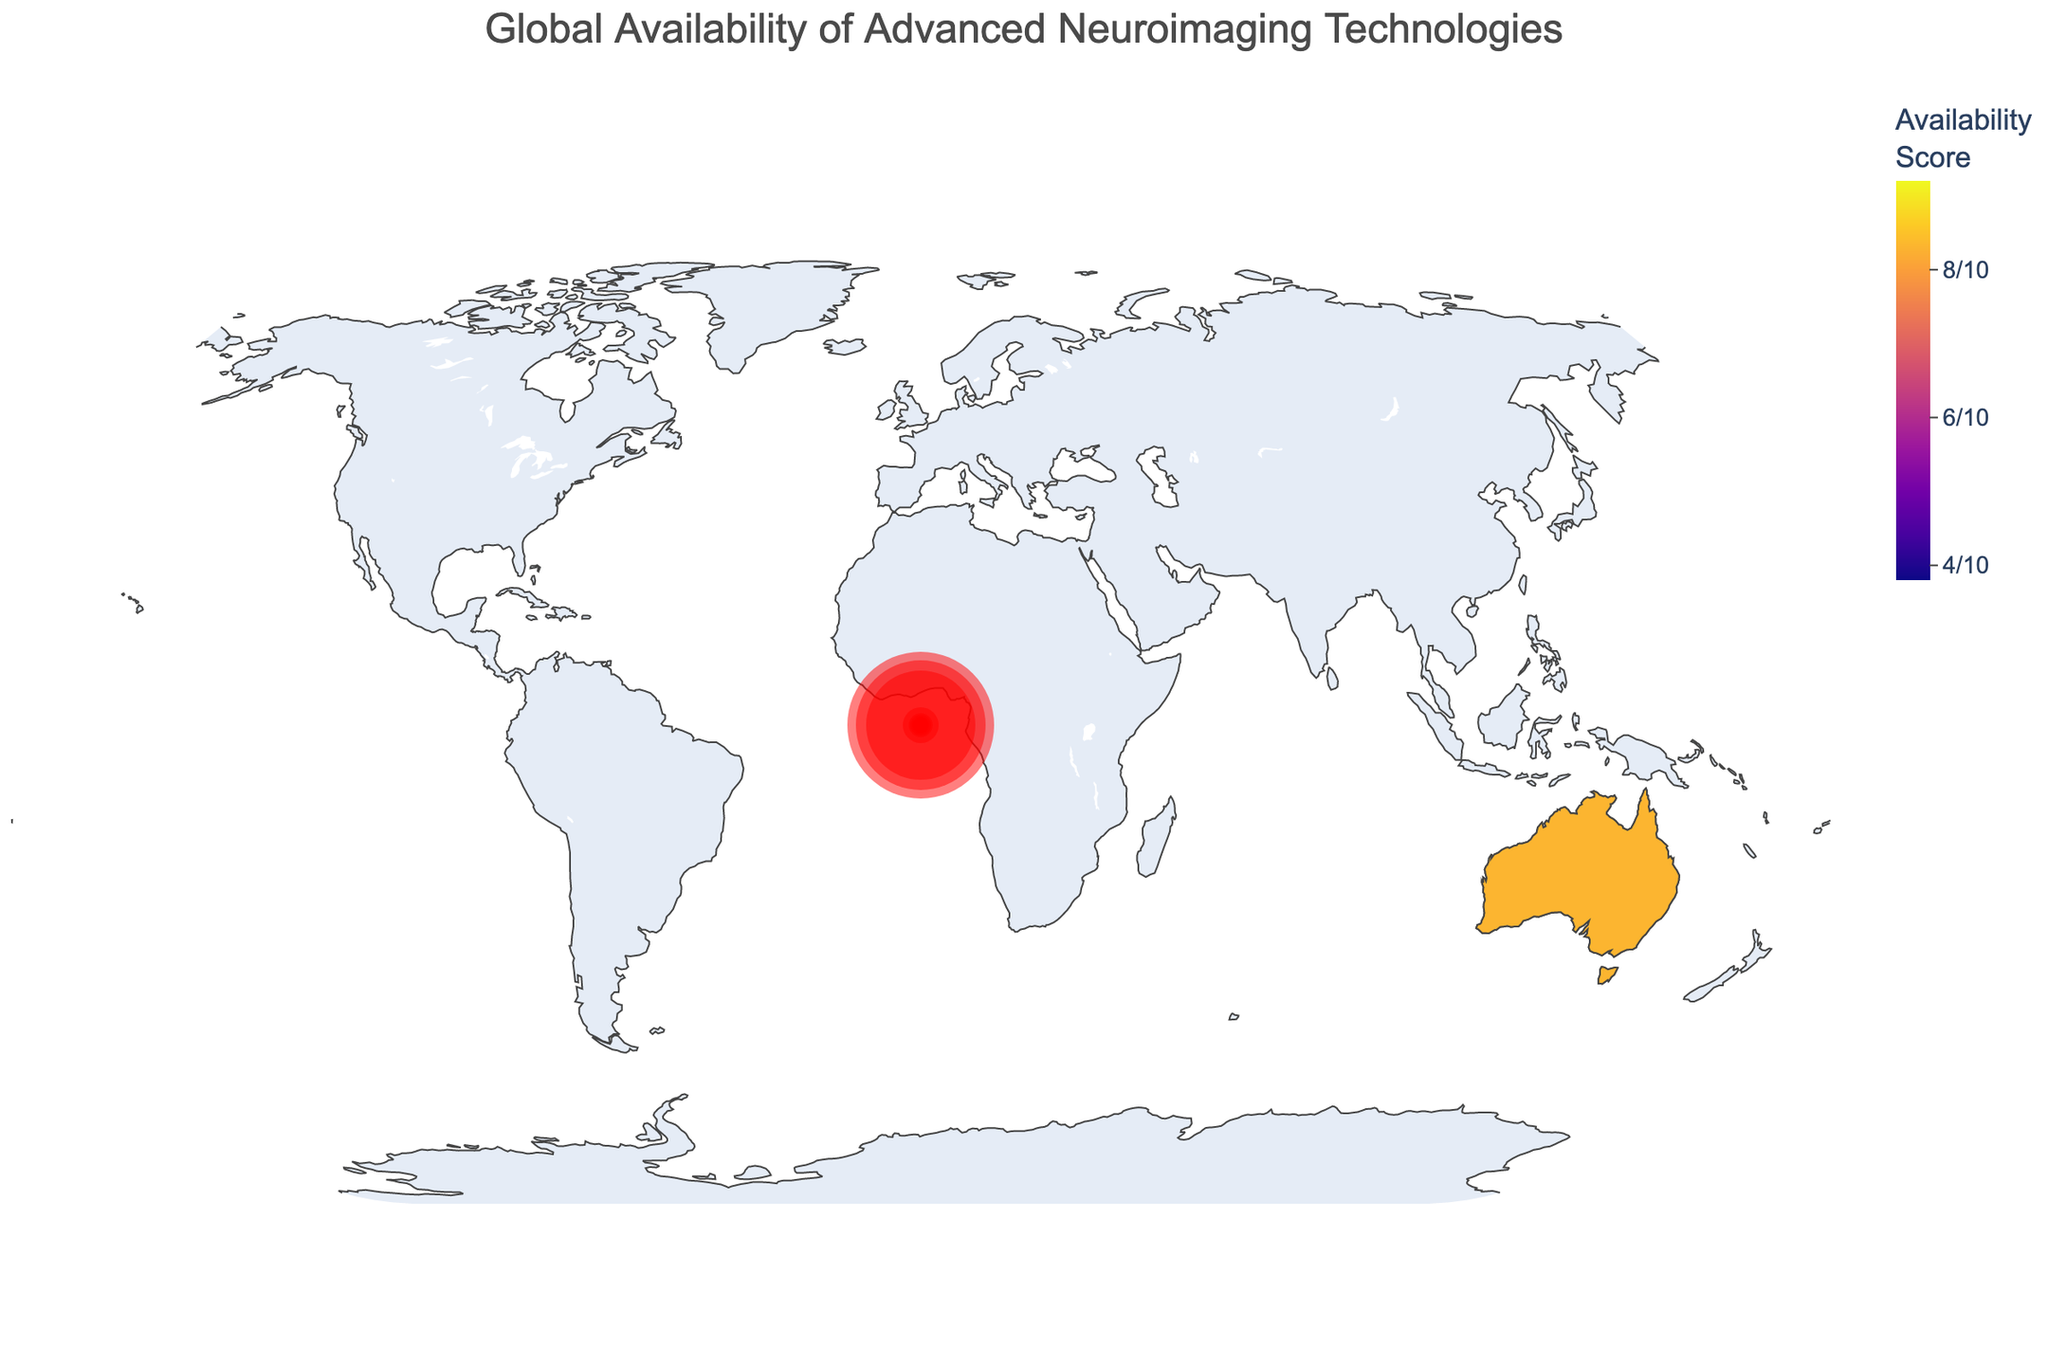Which region has the highest availability score? By examining the color gradient on the map, which represents availability scores, the darkest color signifies the highest score. North America, shown in the darkest shade, has the highest score.
Answer: North America Which region has the lowest number of PET scanners? Looking at the hover data on each region's bubble or by comparing the size of the bubbles, the Caribbean, with its smallest bubble and hover data, shows the lowest number of PET scanners (40).
Answer: Caribbean How many fMRI scanners are available in Western Europe? By hovering over Western Europe on the map, the hover data displays the number of fMRI scanners directly next to the region name, which is 2200.
Answer: 2200 Compare the availability score of South Asia and Central America. Which is higher? By examining the color shades and the hover data of South Asia and Central America, you can see South Asia has a score of 5.5 while Central America has a score of 4.1. Therefore, South Asia has a higher score.
Answer: South Asia What is the total number of scanners (fMRI and PET) in East Asia? Sum the number of fMRI scanners and PET scanners in East Asia by referring to the hover data: 1800 + 1400 = 3200.
Answer: 3200 Identify the region with approximately 300 fMRI scanners and state its availability score. By examining the hover data or bubble sizes, South America comes close to this count with 300 fMRI scanners and has an availability score of 6.2
Answer: South America with an availability score of 6.2 Which regions have an availability score below 5? By examining the color gradient on the map and referring to the legend, the regions with colors indicating a score below 5 are Southeast Asia, South Asia, Africa, Central America, and the Caribbean.
Answer: Southeast Asia, South Asia, Africa, Central America, Caribbean How does the availability score of Western Europe compare to that of East Asia? By examining the hover data or the color gradient, Western Europe has an availability score of 8.9, while East Asia has an availability score of 8.5. Western Europe has a higher availability score than East Asia.
Answer: Western Europe has a higher score What is the combined availability score for Middle East and South America? Add the individual availability scores for Middle East (6.8) and South America (6.2): 6.8 + 6.2 = 13.
Answer: 13 Which region has more fMRI scanners, Eastern Europe or Southeast Asia? By comparing the hover data for both regions, Eastern Europe has 600 fMRI scanners, whereas Southeast Asia has 250 fMRI scanners. Thus, Eastern Europe has more fMRI scanners.
Answer: Eastern Europe 